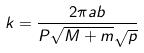Convert formula to latex. <formula><loc_0><loc_0><loc_500><loc_500>k = \frac { 2 \pi a b } { P \sqrt { M + m } \sqrt { p } }</formula> 